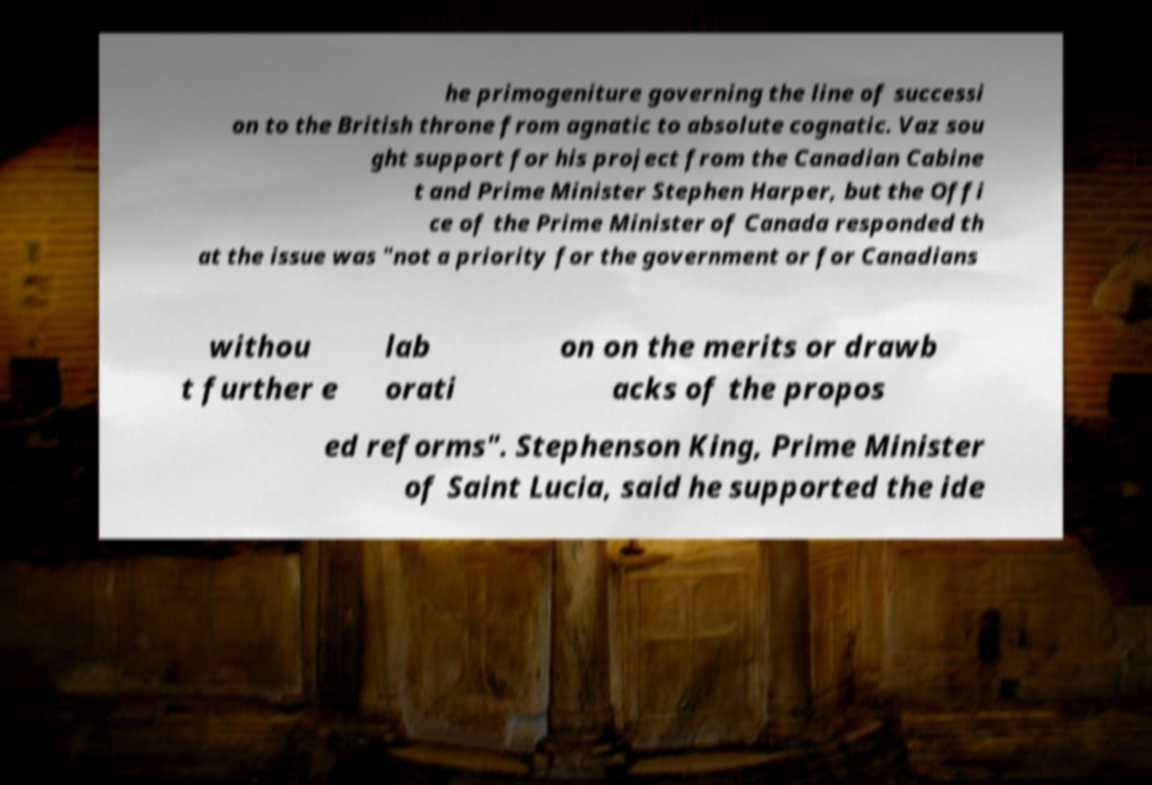Could you extract and type out the text from this image? he primogeniture governing the line of successi on to the British throne from agnatic to absolute cognatic. Vaz sou ght support for his project from the Canadian Cabine t and Prime Minister Stephen Harper, but the Offi ce of the Prime Minister of Canada responded th at the issue was "not a priority for the government or for Canadians withou t further e lab orati on on the merits or drawb acks of the propos ed reforms". Stephenson King, Prime Minister of Saint Lucia, said he supported the ide 